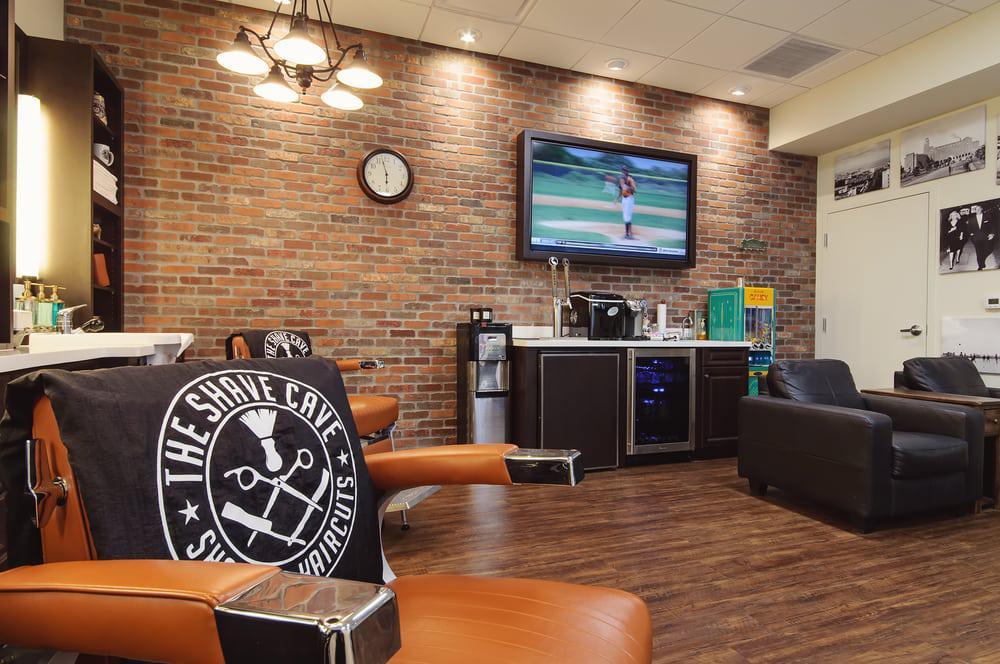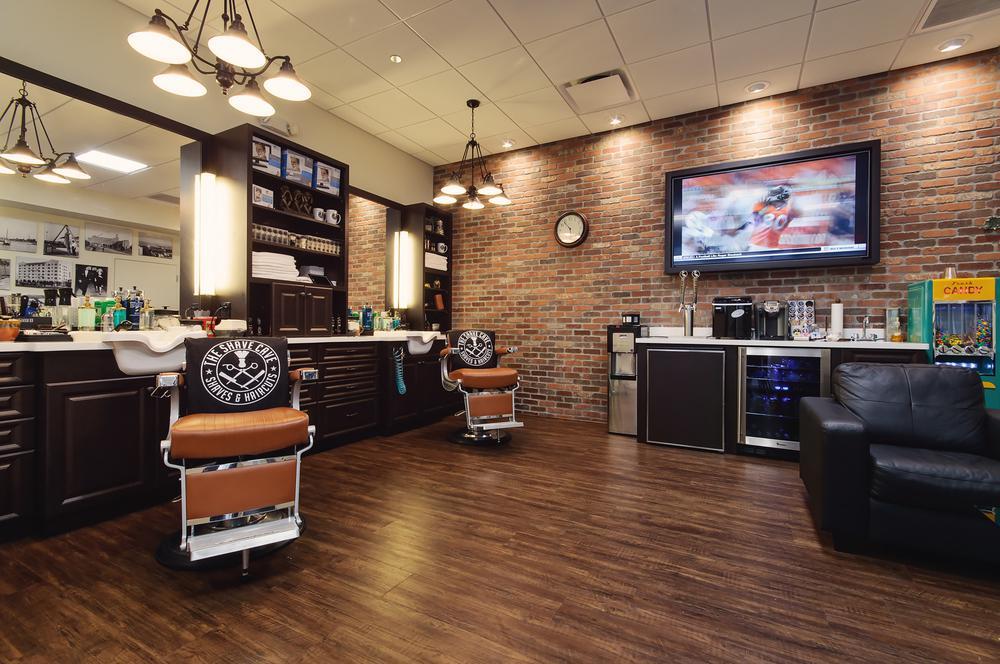The first image is the image on the left, the second image is the image on the right. Considering the images on both sides, is "An exposed brick wall is shown in exactly one image." valid? Answer yes or no. No. 